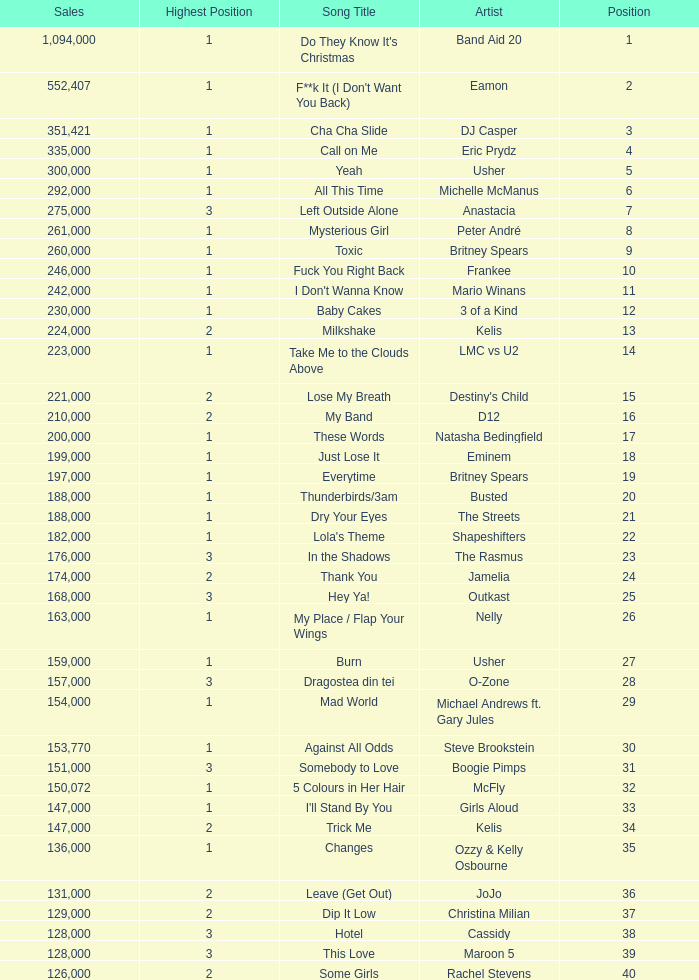What were the sales for Dj Casper when he was in a position lower than 13? 351421.0. 